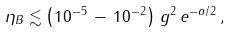Convert formula to latex. <formula><loc_0><loc_0><loc_500><loc_500>\eta _ { B } \lesssim \left ( 1 0 ^ { - 5 } \, - \, 1 0 ^ { - 2 } \right ) \, g ^ { 2 } \, e ^ { - a / 2 } \, ,</formula> 